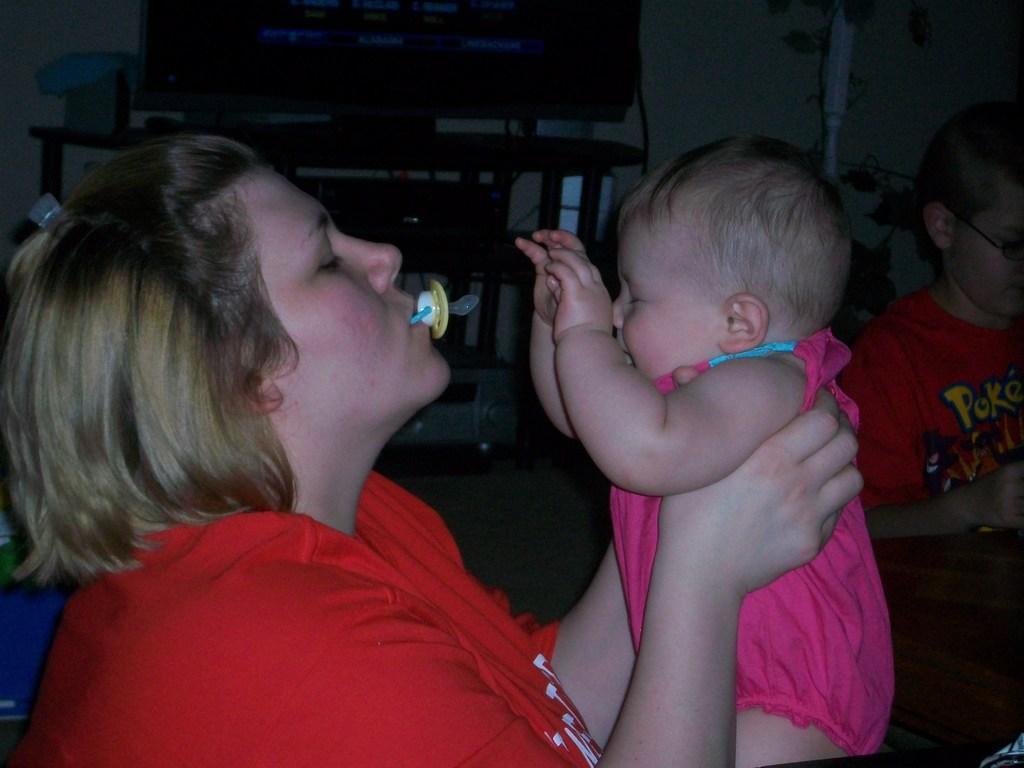Could you give a brief overview of what you see in this image? In this picture we can observe a woman and a child. This woman is holding a child in her hands. She is wearing red color T shirt and the child is wearing pink color dress. On the right side there is another person. We can observe a television placed on the table. 